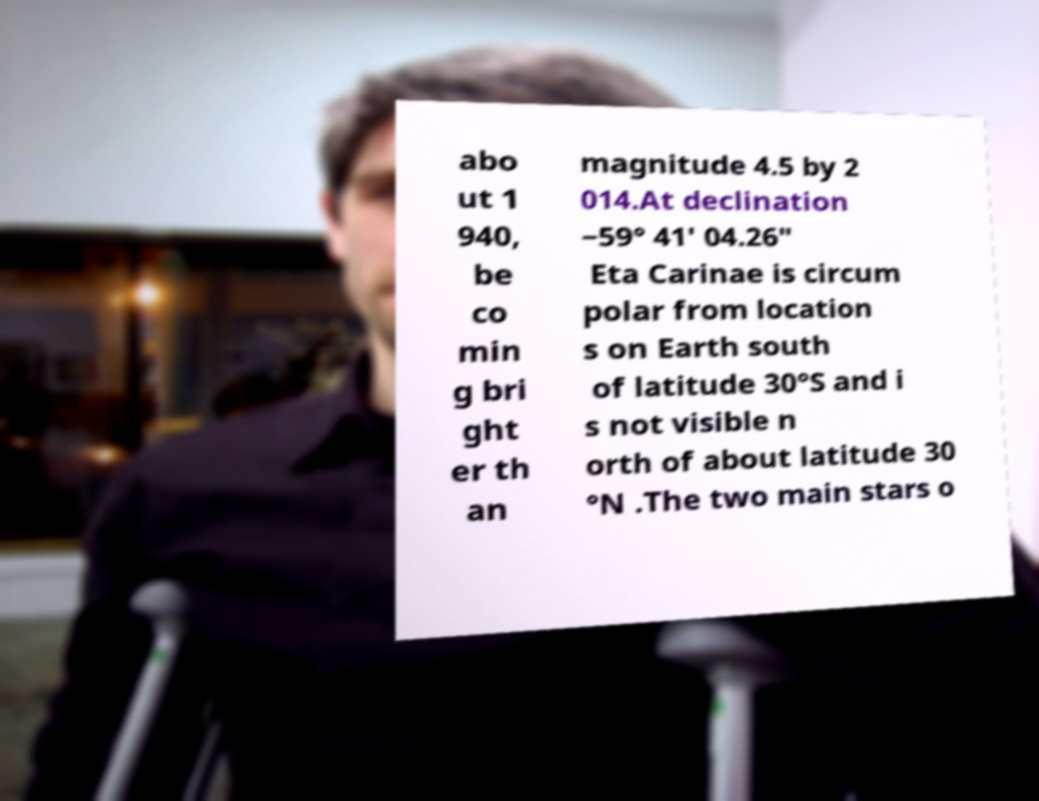Can you read and provide the text displayed in the image?This photo seems to have some interesting text. Can you extract and type it out for me? abo ut 1 940, be co min g bri ght er th an magnitude 4.5 by 2 014.At declination −59° 41′ 04.26″ Eta Carinae is circum polar from location s on Earth south of latitude 30°S and i s not visible n orth of about latitude 30 °N .The two main stars o 